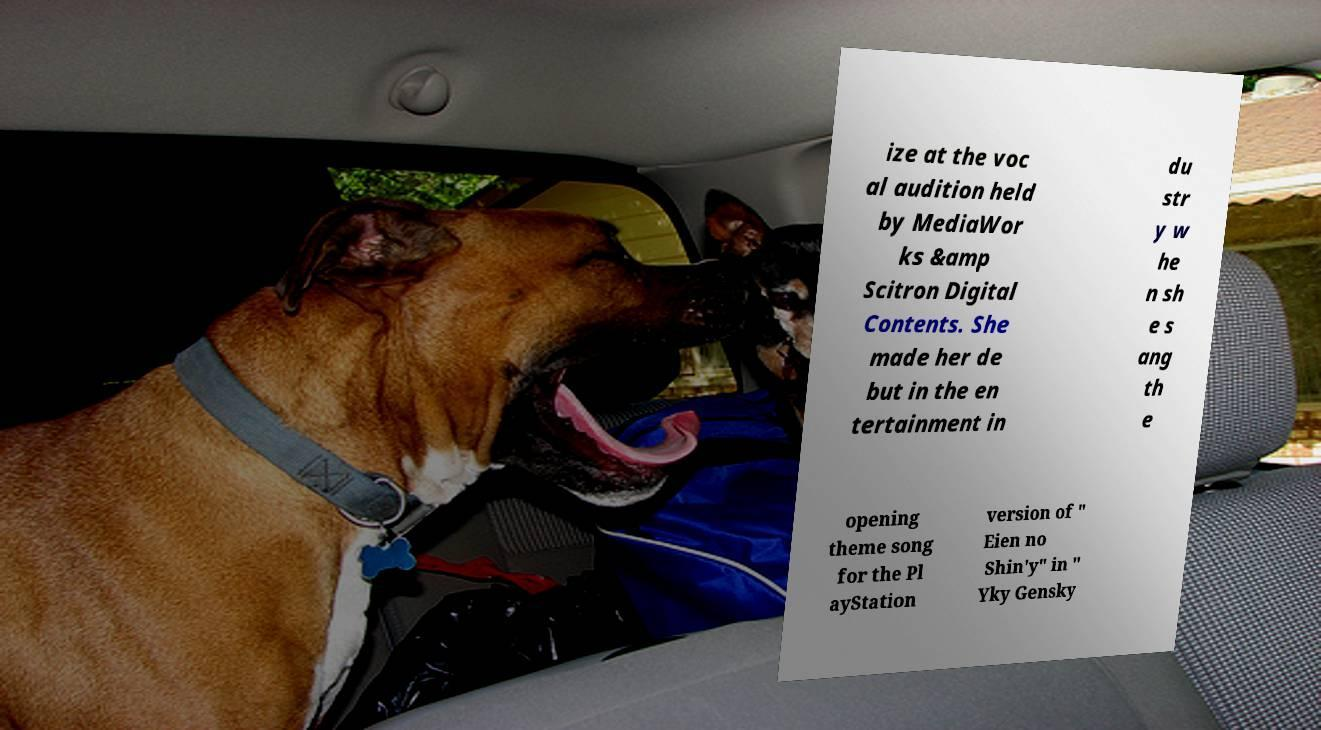Could you assist in decoding the text presented in this image and type it out clearly? ize at the voc al audition held by MediaWor ks &amp Scitron Digital Contents. She made her de but in the en tertainment in du str y w he n sh e s ang th e opening theme song for the Pl ayStation version of " Eien no Shin'y" in " Yky Gensky 